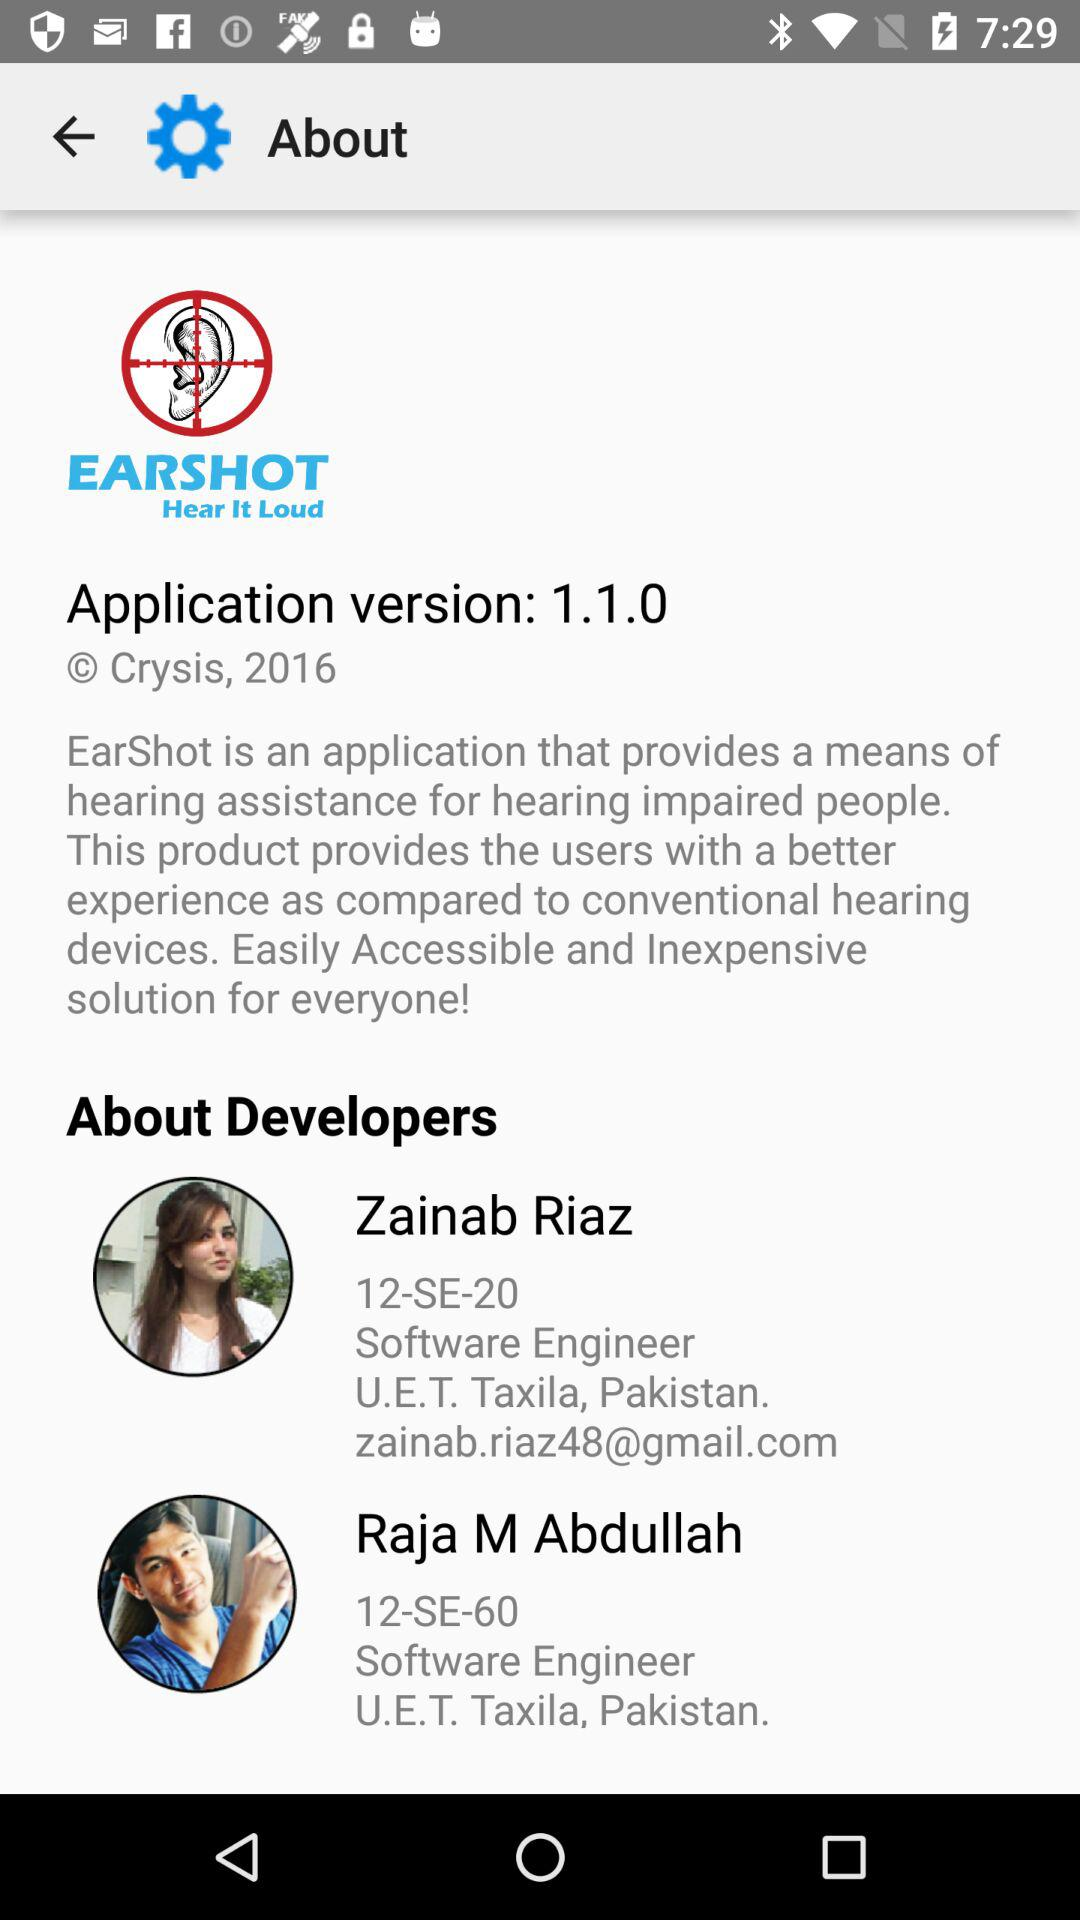Who are the developers? The developers are Zainab Riaz and Raja M. Abdullah. 